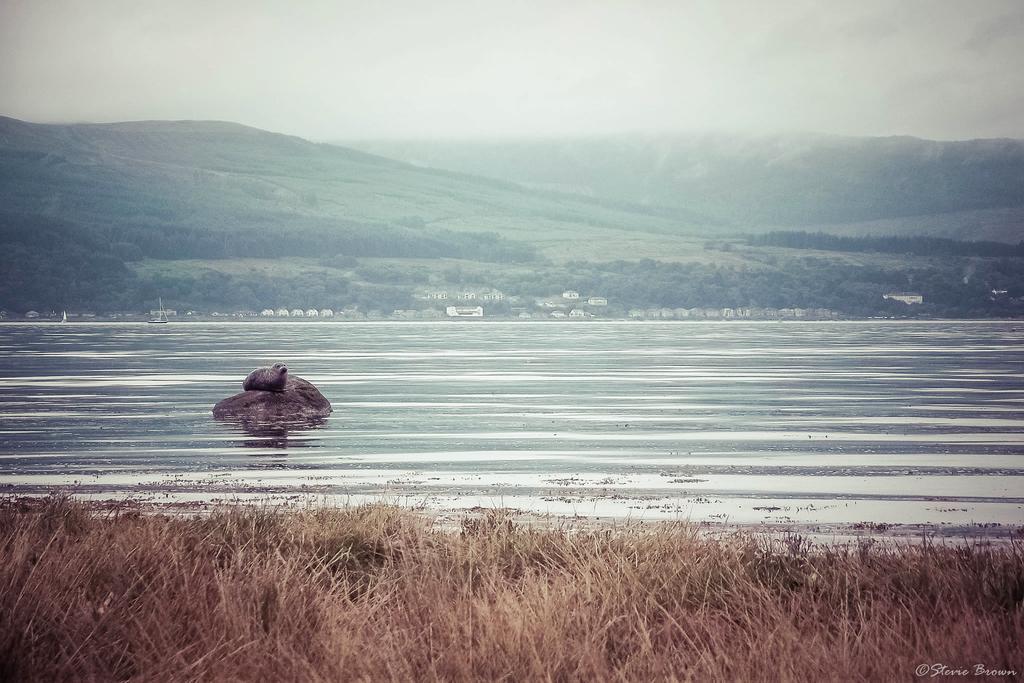Please provide a concise description of this image. In this image we can see water, grass, stones, hills, trees and sky. 